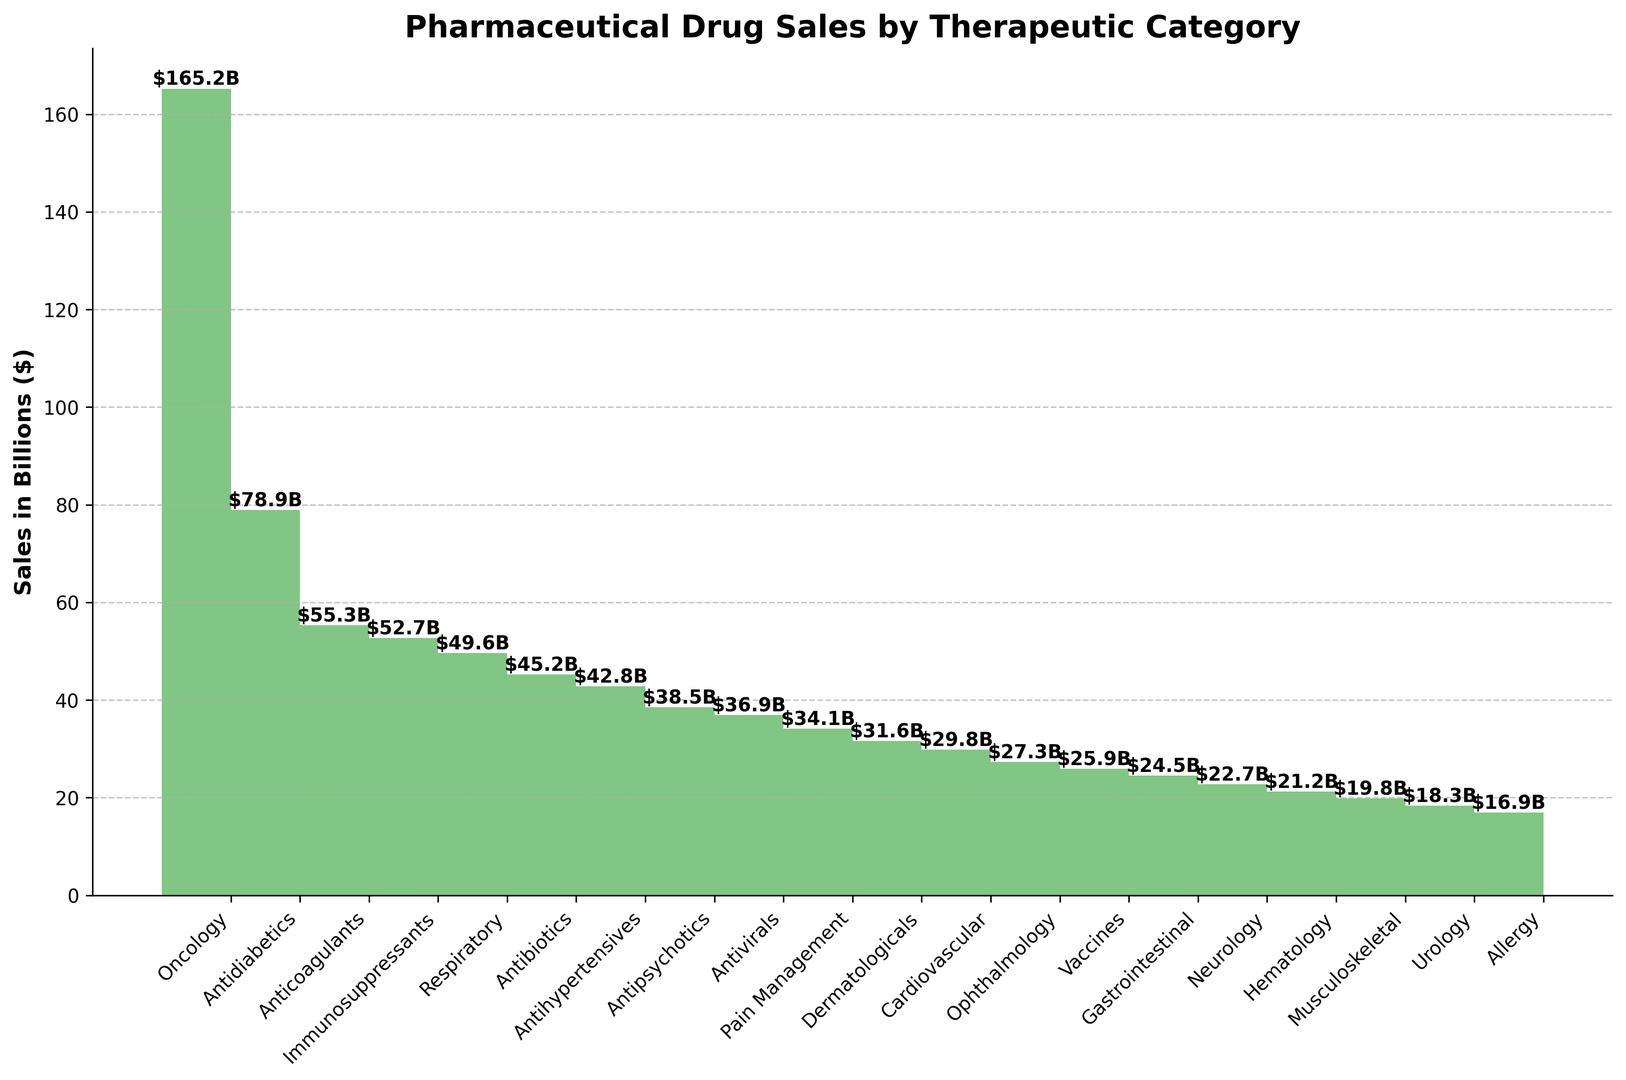what is the sales figure for the therapeutic category with the highest sales? Identify the highest point on the stairs plot, which corresponds to the highest sales figure. Read the sales value from the y-axis and confirm it from the label on the bar.
Answer: $165.2B Which therapeutic category has the lowest sales, and what is the sales figure? Identify the lowest point on the stairs plot, which corresponds to the lowest sales figure. Read the sales value from the y-axis and confirm it from the label on the bar.
Answer: Allergy, $16.9B What is the total sales figure for Antidiabetics and Anticoagulants combined? Find the sales figures for both Antidiabetics ($78.9B) and Anticoagulants ($55.3B). Sum these figures to get the total sales. $78.9B + $55.3B = $134.2B
Answer: $134.2B How much more are the sales for Oncology compared to Pain Management? Find the sales figures for Oncology ($165.2B) and Pain Management ($34.1B). Subtract the sales of Pain Management from Oncology. $165.2B - $34.1B = $131.1B
Answer: $131.1B Which therapeutic category has sales just below Antipsychotics, and what is its sales figure? Locate Antipsychotics on the stairs plot and identify the bar immediately preceding it. The label and sales figure for this category will be directly to the left of Antipsychotics.
Answer: Antihypertensives, $42.8B What is the average sales figure of the top 5 therapeutic categories? Identify the top 5 therapeutic categories and their sales: Oncology ($165.2B), Antidiabetics ($78.9B), Anticoagulants ($55.3B), Immunosuppressants ($52.7B), and Respiratory ($49.6B). Sum these figures and divide by 5 to get the average. ($165.2B + $78.9B + $55.3B + $52.7B + $49.6B) / 5 = $80.34B
Answer: $80.34B Which therapeutic category has sales equal to or less than 30 billion dollars but more than 25 billion dollars? Identify the bars with sales figures in the specified range (25B < sales ≤ 30B). Refer to the labels to find the corresponding therapeutic category.
Answer: Cardiovascular, $29.8B Among the categories highlighted in the plot, name one that has a sales figure closest to the median value of all the categories? List all the sales figures and find the median value. Identify the category whose sales are closest to this median value.
Answer: Neurology, $22.7B What is the difference between the total sales of the top 3 categories and the bottom 3 categories? Identify the top 3 sales figures: Oncology ($165.2B), Antidiabetics ($78.9B), Anticoagulants ($55.3B). Sum these figures to get the top 3 total: $165.2B + $78.9B + $55.3B = $299.4B. Identify the bottom 3 sales figures: Hematology ($21.2B), Musculoskeletal ($19.8B), Allergy ($16.9B). Sum these to get the bottom 3 total: $21.2B + $19.8B + $16.9B = $57.9B. Subtract the bottom 3 total from the top 3 total: $299.4B - $57.9B = $241.5B
Answer: $241.5B 